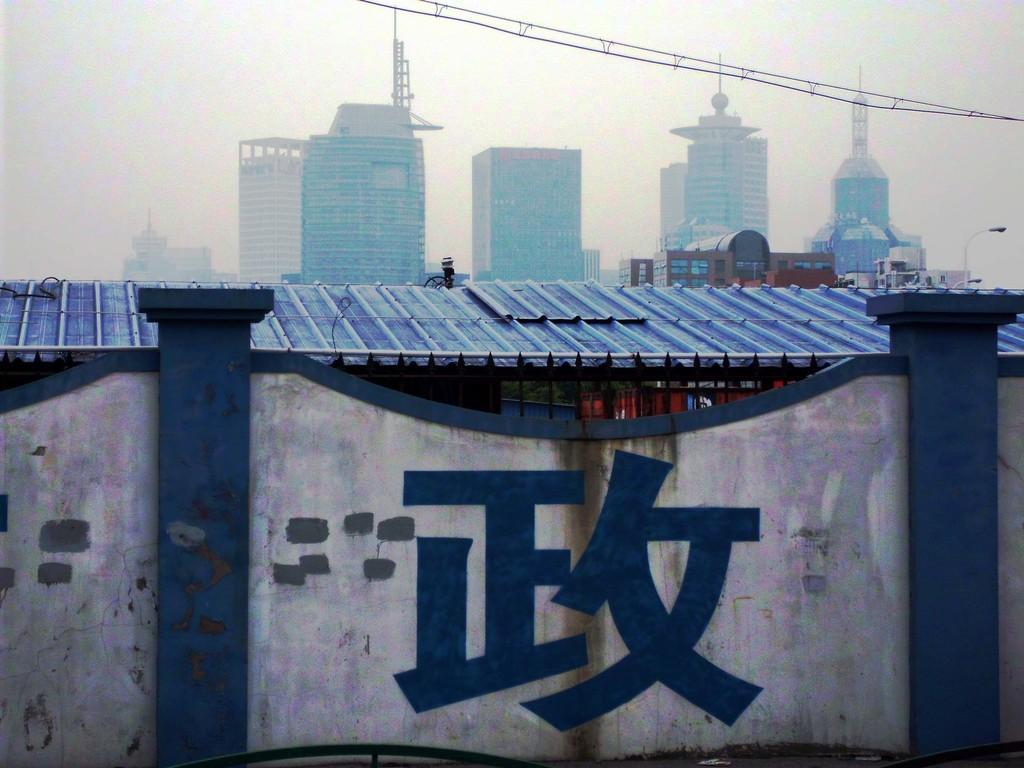What type of structure is present in the image? There is a shed in the image. What can be seen in the distance behind the shed? There are skyscrapers in the background of the image. What other object is visible in the background of the image? There is a light with a pole in the background of the image. What part of the natural environment is visible in the image? The sky is visible in the background of the image. What type of club can be seen in the image? There is no club present in the image. How many dolls are sitting on the roof of the shed in the image? There are no dolls present in the image. 